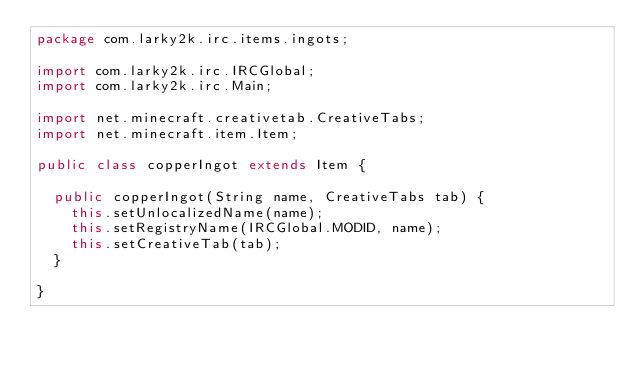<code> <loc_0><loc_0><loc_500><loc_500><_Java_>package com.larky2k.irc.items.ingots;

import com.larky2k.irc.IRCGlobal;
import com.larky2k.irc.Main;

import net.minecraft.creativetab.CreativeTabs;
import net.minecraft.item.Item;

public class copperIngot extends Item {
	
	public copperIngot(String name, CreativeTabs tab) {
		this.setUnlocalizedName(name);
		this.setRegistryName(IRCGlobal.MODID, name);
		this.setCreativeTab(tab);
	}
	
}
</code> 